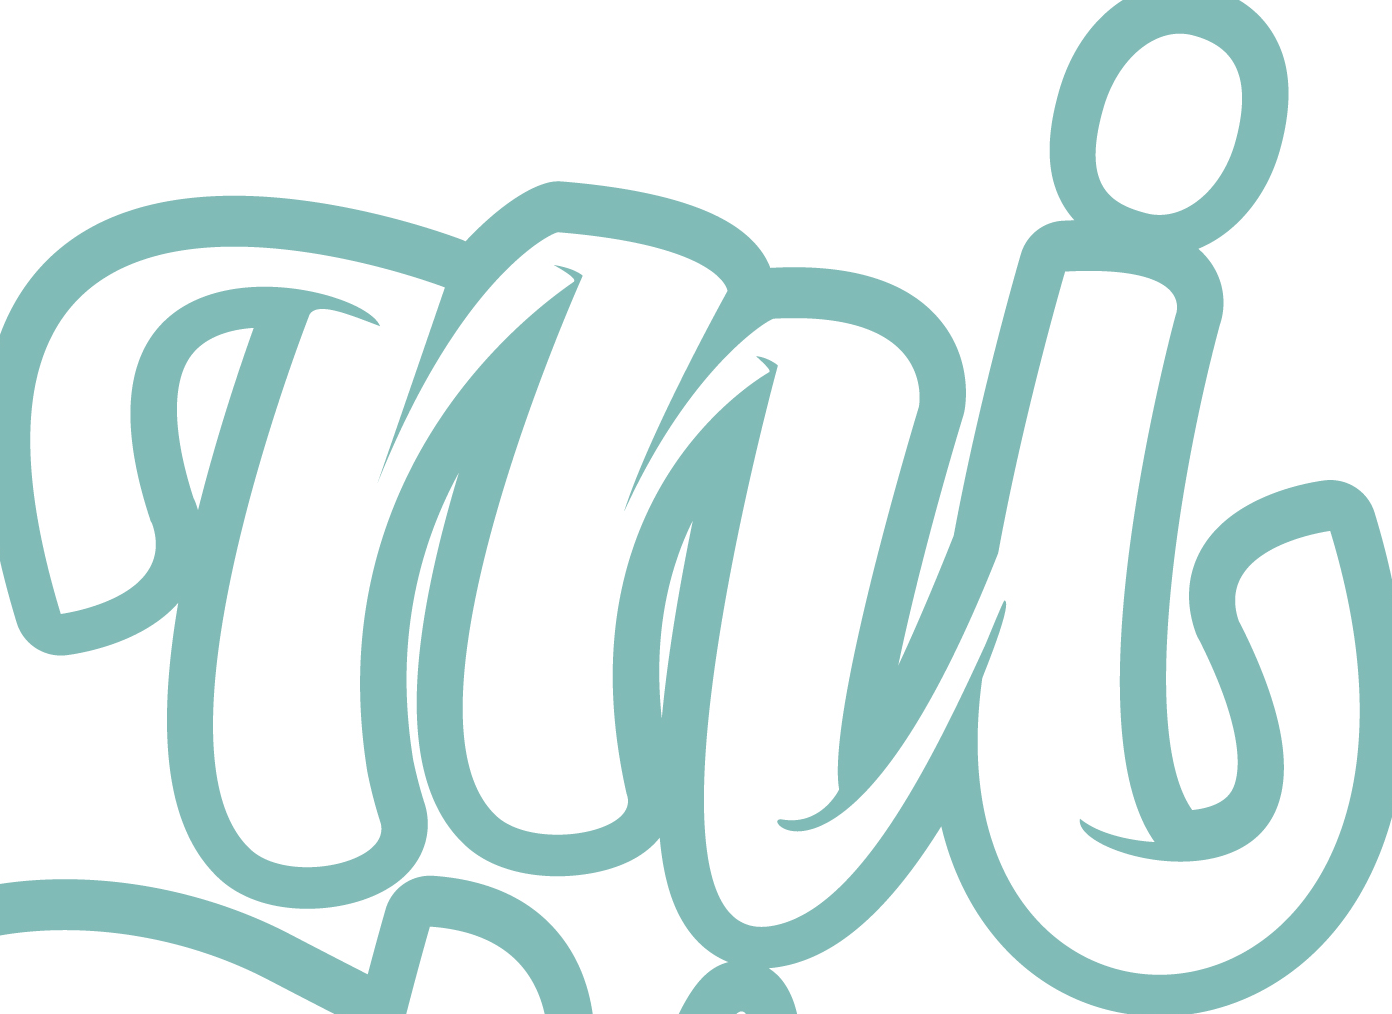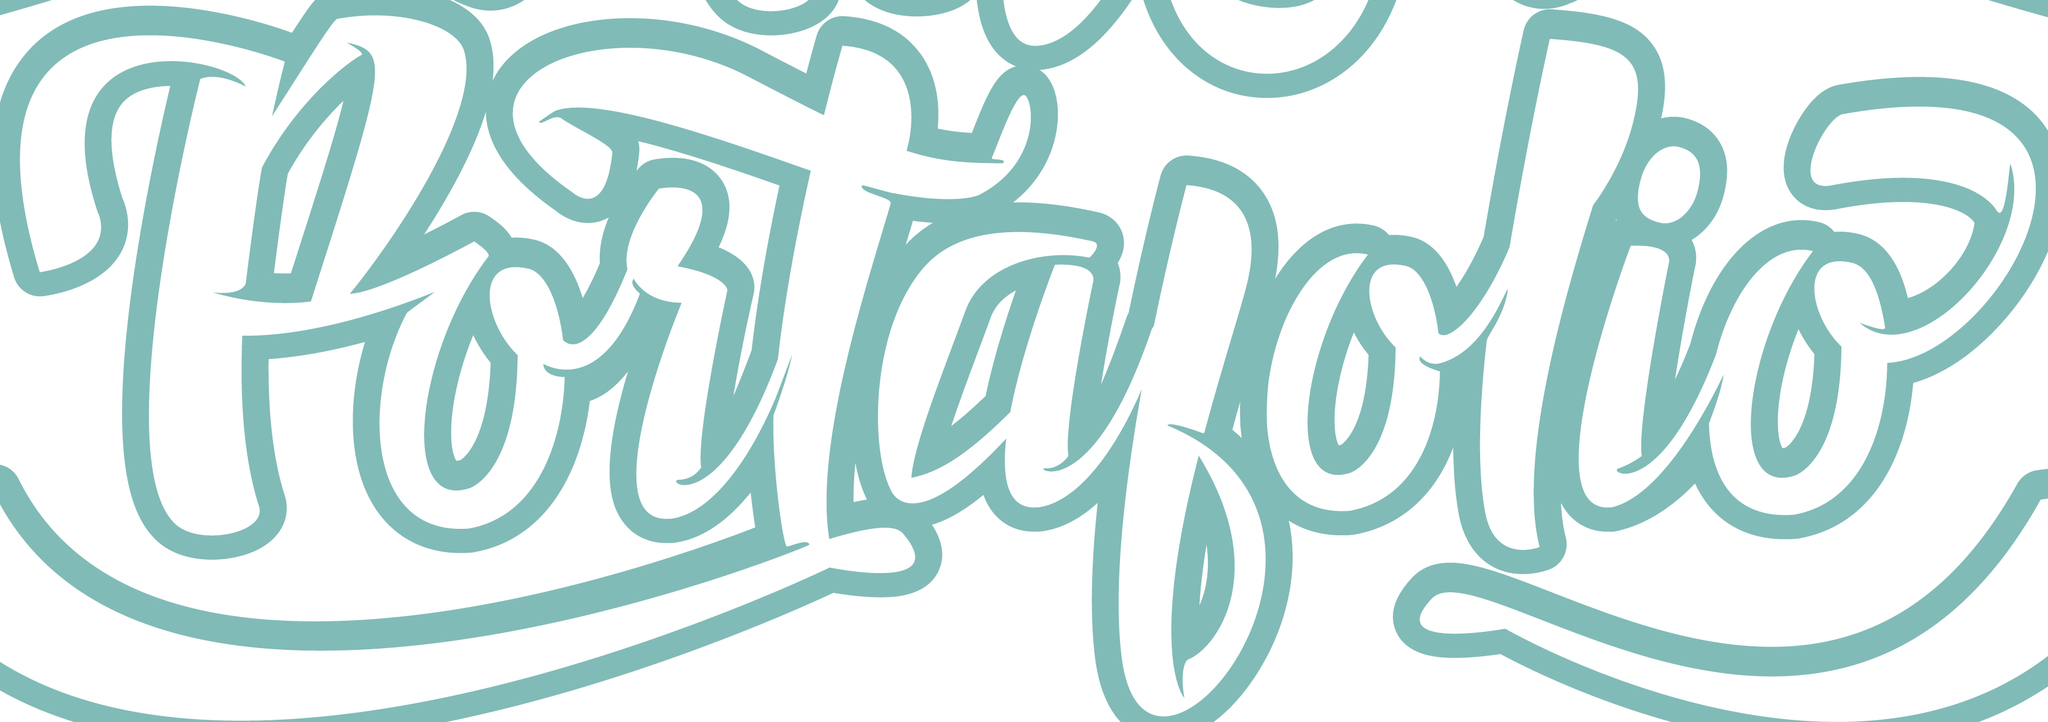Read the text from these images in sequence, separated by a semicolon. mi; portalolio 